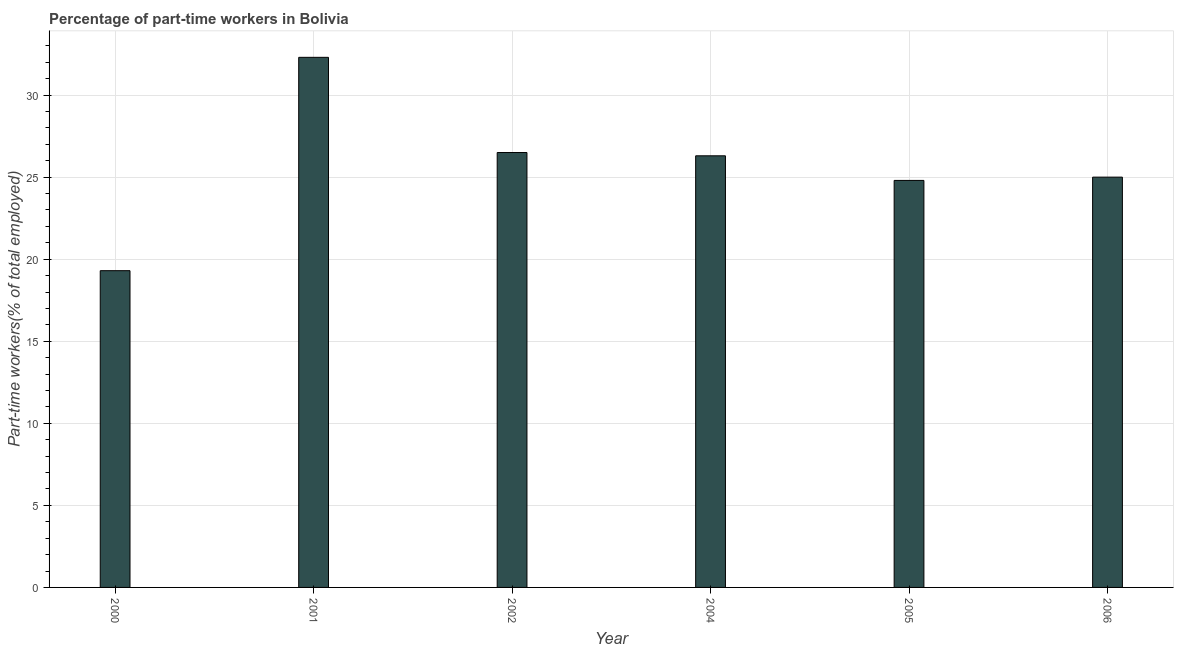Does the graph contain any zero values?
Keep it short and to the point. No. What is the title of the graph?
Your answer should be compact. Percentage of part-time workers in Bolivia. What is the label or title of the X-axis?
Ensure brevity in your answer.  Year. What is the label or title of the Y-axis?
Give a very brief answer. Part-time workers(% of total employed). What is the percentage of part-time workers in 2005?
Provide a succinct answer. 24.8. Across all years, what is the maximum percentage of part-time workers?
Offer a terse response. 32.3. Across all years, what is the minimum percentage of part-time workers?
Your answer should be compact. 19.3. In which year was the percentage of part-time workers minimum?
Give a very brief answer. 2000. What is the sum of the percentage of part-time workers?
Keep it short and to the point. 154.2. What is the average percentage of part-time workers per year?
Provide a succinct answer. 25.7. What is the median percentage of part-time workers?
Keep it short and to the point. 25.65. Do a majority of the years between 2004 and 2005 (inclusive) have percentage of part-time workers greater than 1 %?
Ensure brevity in your answer.  Yes. What is the ratio of the percentage of part-time workers in 2000 to that in 2002?
Keep it short and to the point. 0.73. Is the percentage of part-time workers in 2002 less than that in 2004?
Give a very brief answer. No. Is the difference between the percentage of part-time workers in 2004 and 2006 greater than the difference between any two years?
Your response must be concise. No. What is the difference between the highest and the second highest percentage of part-time workers?
Provide a short and direct response. 5.8. Is the sum of the percentage of part-time workers in 2004 and 2005 greater than the maximum percentage of part-time workers across all years?
Offer a terse response. Yes. Are all the bars in the graph horizontal?
Your answer should be very brief. No. What is the Part-time workers(% of total employed) of 2000?
Provide a short and direct response. 19.3. What is the Part-time workers(% of total employed) in 2001?
Keep it short and to the point. 32.3. What is the Part-time workers(% of total employed) in 2002?
Provide a succinct answer. 26.5. What is the Part-time workers(% of total employed) in 2004?
Keep it short and to the point. 26.3. What is the Part-time workers(% of total employed) in 2005?
Ensure brevity in your answer.  24.8. What is the difference between the Part-time workers(% of total employed) in 2000 and 2001?
Your response must be concise. -13. What is the difference between the Part-time workers(% of total employed) in 2000 and 2002?
Your answer should be compact. -7.2. What is the difference between the Part-time workers(% of total employed) in 2000 and 2004?
Your answer should be very brief. -7. What is the difference between the Part-time workers(% of total employed) in 2000 and 2005?
Your answer should be very brief. -5.5. What is the difference between the Part-time workers(% of total employed) in 2000 and 2006?
Give a very brief answer. -5.7. What is the difference between the Part-time workers(% of total employed) in 2001 and 2004?
Make the answer very short. 6. What is the difference between the Part-time workers(% of total employed) in 2002 and 2004?
Your response must be concise. 0.2. What is the difference between the Part-time workers(% of total employed) in 2002 and 2006?
Give a very brief answer. 1.5. What is the difference between the Part-time workers(% of total employed) in 2004 and 2006?
Ensure brevity in your answer.  1.3. What is the ratio of the Part-time workers(% of total employed) in 2000 to that in 2001?
Your answer should be compact. 0.6. What is the ratio of the Part-time workers(% of total employed) in 2000 to that in 2002?
Your answer should be compact. 0.73. What is the ratio of the Part-time workers(% of total employed) in 2000 to that in 2004?
Your response must be concise. 0.73. What is the ratio of the Part-time workers(% of total employed) in 2000 to that in 2005?
Give a very brief answer. 0.78. What is the ratio of the Part-time workers(% of total employed) in 2000 to that in 2006?
Keep it short and to the point. 0.77. What is the ratio of the Part-time workers(% of total employed) in 2001 to that in 2002?
Your answer should be compact. 1.22. What is the ratio of the Part-time workers(% of total employed) in 2001 to that in 2004?
Offer a very short reply. 1.23. What is the ratio of the Part-time workers(% of total employed) in 2001 to that in 2005?
Provide a short and direct response. 1.3. What is the ratio of the Part-time workers(% of total employed) in 2001 to that in 2006?
Your response must be concise. 1.29. What is the ratio of the Part-time workers(% of total employed) in 2002 to that in 2005?
Provide a short and direct response. 1.07. What is the ratio of the Part-time workers(% of total employed) in 2002 to that in 2006?
Make the answer very short. 1.06. What is the ratio of the Part-time workers(% of total employed) in 2004 to that in 2005?
Provide a short and direct response. 1.06. What is the ratio of the Part-time workers(% of total employed) in 2004 to that in 2006?
Keep it short and to the point. 1.05. What is the ratio of the Part-time workers(% of total employed) in 2005 to that in 2006?
Make the answer very short. 0.99. 